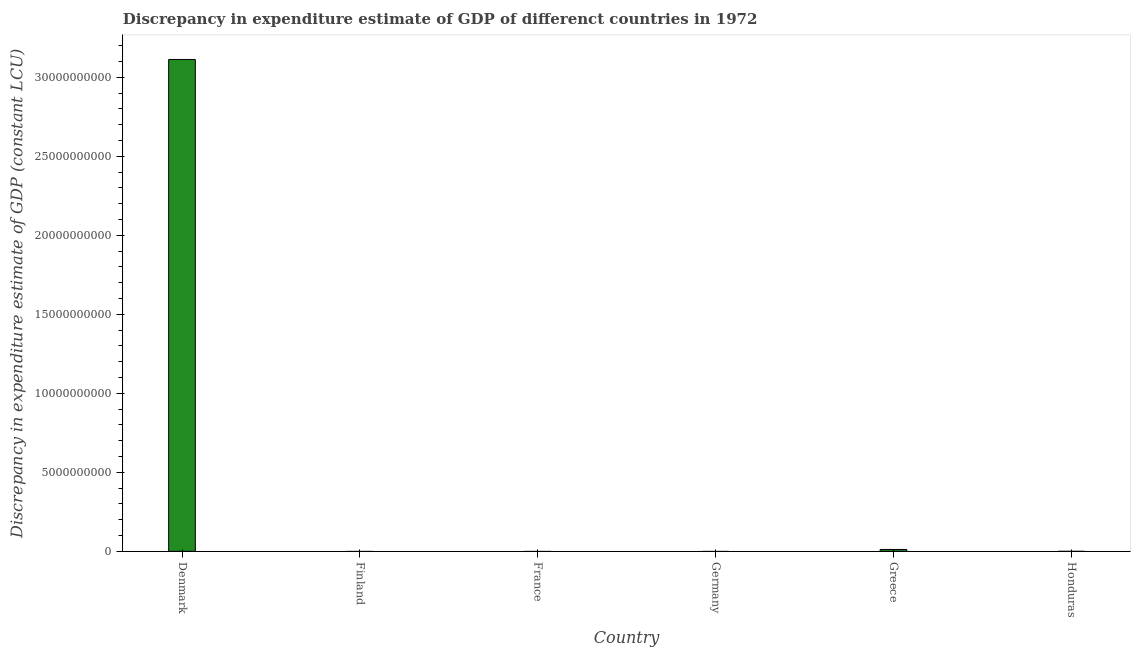What is the title of the graph?
Provide a succinct answer. Discrepancy in expenditure estimate of GDP of differenct countries in 1972. What is the label or title of the Y-axis?
Your answer should be very brief. Discrepancy in expenditure estimate of GDP (constant LCU). What is the discrepancy in expenditure estimate of gdp in Germany?
Your answer should be very brief. 0. Across all countries, what is the maximum discrepancy in expenditure estimate of gdp?
Ensure brevity in your answer.  3.11e+1. Across all countries, what is the minimum discrepancy in expenditure estimate of gdp?
Offer a very short reply. 0. In which country was the discrepancy in expenditure estimate of gdp maximum?
Offer a terse response. Denmark. What is the sum of the discrepancy in expenditure estimate of gdp?
Make the answer very short. 3.13e+1. What is the difference between the discrepancy in expenditure estimate of gdp in Greece and Honduras?
Give a very brief answer. 1.20e+08. What is the average discrepancy in expenditure estimate of gdp per country?
Make the answer very short. 5.21e+09. What is the median discrepancy in expenditure estimate of gdp?
Your answer should be very brief. 1.80e+04. In how many countries, is the discrepancy in expenditure estimate of gdp greater than 8000000000 LCU?
Give a very brief answer. 1. What is the ratio of the discrepancy in expenditure estimate of gdp in Denmark to that in Honduras?
Offer a very short reply. 8.65e+05. What is the difference between the highest and the second highest discrepancy in expenditure estimate of gdp?
Keep it short and to the point. 3.10e+1. What is the difference between the highest and the lowest discrepancy in expenditure estimate of gdp?
Ensure brevity in your answer.  3.11e+1. How many bars are there?
Offer a very short reply. 3. How many countries are there in the graph?
Offer a terse response. 6. What is the difference between two consecutive major ticks on the Y-axis?
Offer a very short reply. 5.00e+09. What is the Discrepancy in expenditure estimate of GDP (constant LCU) in Denmark?
Your answer should be very brief. 3.11e+1. What is the Discrepancy in expenditure estimate of GDP (constant LCU) of France?
Your response must be concise. 0. What is the Discrepancy in expenditure estimate of GDP (constant LCU) of Germany?
Offer a very short reply. 0. What is the Discrepancy in expenditure estimate of GDP (constant LCU) of Greece?
Your answer should be compact. 1.20e+08. What is the Discrepancy in expenditure estimate of GDP (constant LCU) of Honduras?
Offer a terse response. 3.60e+04. What is the difference between the Discrepancy in expenditure estimate of GDP (constant LCU) in Denmark and Greece?
Provide a succinct answer. 3.10e+1. What is the difference between the Discrepancy in expenditure estimate of GDP (constant LCU) in Denmark and Honduras?
Keep it short and to the point. 3.11e+1. What is the difference between the Discrepancy in expenditure estimate of GDP (constant LCU) in Greece and Honduras?
Offer a very short reply. 1.20e+08. What is the ratio of the Discrepancy in expenditure estimate of GDP (constant LCU) in Denmark to that in Greece?
Your response must be concise. 260.01. What is the ratio of the Discrepancy in expenditure estimate of GDP (constant LCU) in Denmark to that in Honduras?
Keep it short and to the point. 8.65e+05. What is the ratio of the Discrepancy in expenditure estimate of GDP (constant LCU) in Greece to that in Honduras?
Ensure brevity in your answer.  3326.22. 